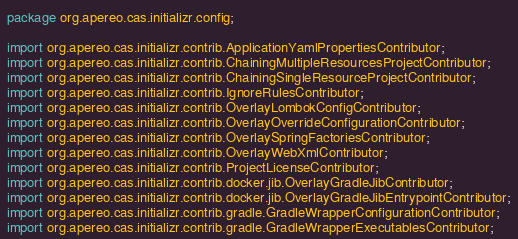Convert code to text. <code><loc_0><loc_0><loc_500><loc_500><_Java_>package org.apereo.cas.initializr.config;

import org.apereo.cas.initializr.contrib.ApplicationYamlPropertiesContributor;
import org.apereo.cas.initializr.contrib.ChainingMultipleResourcesProjectContributor;
import org.apereo.cas.initializr.contrib.ChainingSingleResourceProjectContributor;
import org.apereo.cas.initializr.contrib.IgnoreRulesContributor;
import org.apereo.cas.initializr.contrib.OverlayLombokConfigContributor;
import org.apereo.cas.initializr.contrib.OverlayOverrideConfigurationContributor;
import org.apereo.cas.initializr.contrib.OverlaySpringFactoriesContributor;
import org.apereo.cas.initializr.contrib.OverlayWebXmlContributor;
import org.apereo.cas.initializr.contrib.ProjectLicenseContributor;
import org.apereo.cas.initializr.contrib.docker.jib.OverlayGradleJibContributor;
import org.apereo.cas.initializr.contrib.docker.jib.OverlayGradleJibEntrypointContributor;
import org.apereo.cas.initializr.contrib.gradle.GradleWrapperConfigurationContributor;
import org.apereo.cas.initializr.contrib.gradle.GradleWrapperExecutablesContributor;</code> 